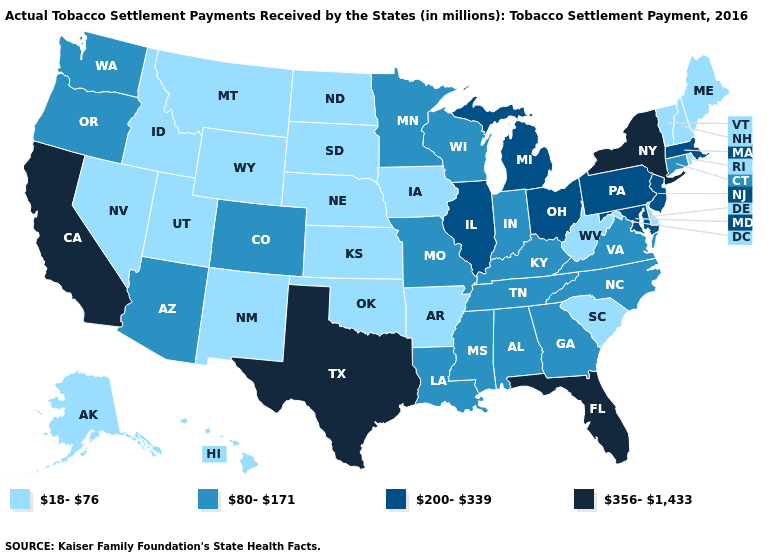How many symbols are there in the legend?
Answer briefly. 4. Does Kansas have the lowest value in the USA?
Answer briefly. Yes. Name the states that have a value in the range 200-339?
Write a very short answer. Illinois, Maryland, Massachusetts, Michigan, New Jersey, Ohio, Pennsylvania. Does the map have missing data?
Concise answer only. No. Among the states that border Oklahoma , which have the lowest value?
Be succinct. Arkansas, Kansas, New Mexico. Does Maine have the lowest value in the USA?
Give a very brief answer. Yes. Name the states that have a value in the range 18-76?
Be succinct. Alaska, Arkansas, Delaware, Hawaii, Idaho, Iowa, Kansas, Maine, Montana, Nebraska, Nevada, New Hampshire, New Mexico, North Dakota, Oklahoma, Rhode Island, South Carolina, South Dakota, Utah, Vermont, West Virginia, Wyoming. What is the highest value in the USA?
Concise answer only. 356-1,433. What is the value of Alabama?
Short answer required. 80-171. What is the value of North Dakota?
Quick response, please. 18-76. What is the highest value in states that border California?
Write a very short answer. 80-171. Does North Dakota have a higher value than North Carolina?
Give a very brief answer. No. Does Arkansas have a lower value than Alaska?
Quick response, please. No. Which states have the lowest value in the West?
Answer briefly. Alaska, Hawaii, Idaho, Montana, Nevada, New Mexico, Utah, Wyoming. Does South Carolina have a higher value than Kentucky?
Be succinct. No. 